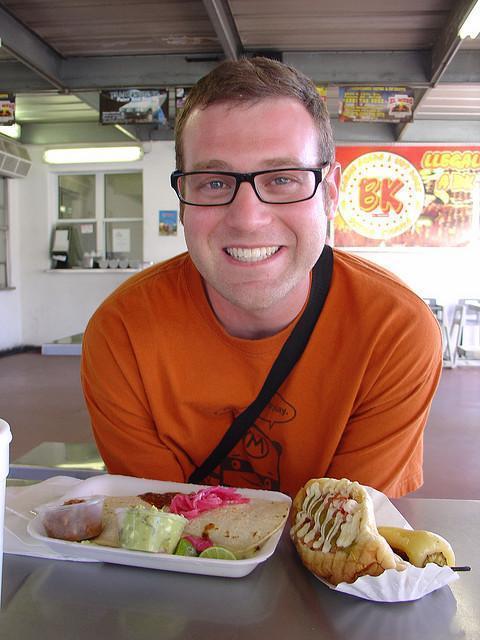How many people are looking at the camera?
Give a very brief answer. 1. 